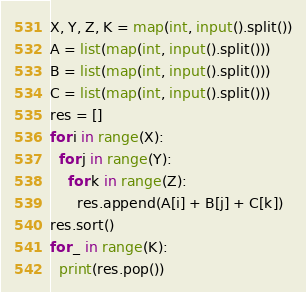<code> <loc_0><loc_0><loc_500><loc_500><_Python_>X, Y, Z, K = map(int, input().split())
A = list(map(int, input().split()))
B = list(map(int, input().split()))
C = list(map(int, input().split()))
res = []
for i in range(X):
  for j in range(Y):
    for k in range(Z):
      res.append(A[i] + B[j] + C[k])
res.sort()
for _ in range(K):
  print(res.pop())</code> 